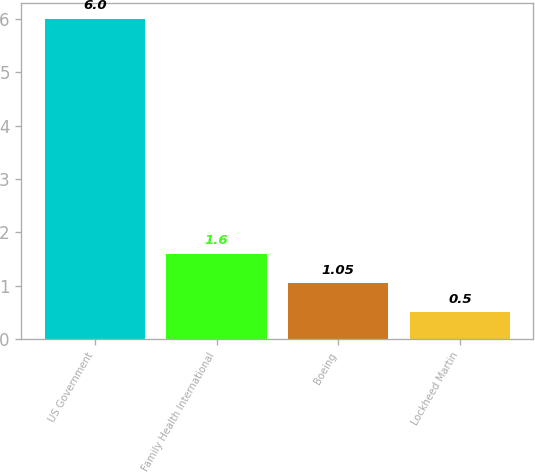Convert chart to OTSL. <chart><loc_0><loc_0><loc_500><loc_500><bar_chart><fcel>US Government<fcel>Family Health International<fcel>Boeing<fcel>Lockheed Martin<nl><fcel>6<fcel>1.6<fcel>1.05<fcel>0.5<nl></chart> 